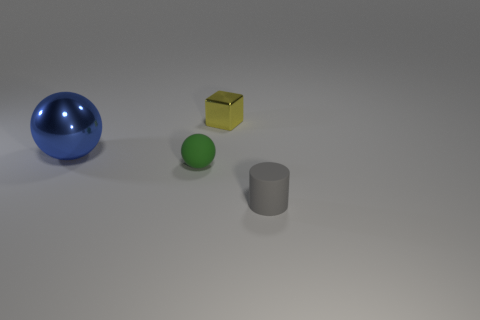Add 3 blue shiny objects. How many objects exist? 7 Subtract all cylinders. How many objects are left? 3 Add 1 tiny cylinders. How many tiny cylinders are left? 2 Add 2 cyan matte balls. How many cyan matte balls exist? 2 Subtract 1 blue spheres. How many objects are left? 3 Subtract all small green balls. Subtract all blocks. How many objects are left? 2 